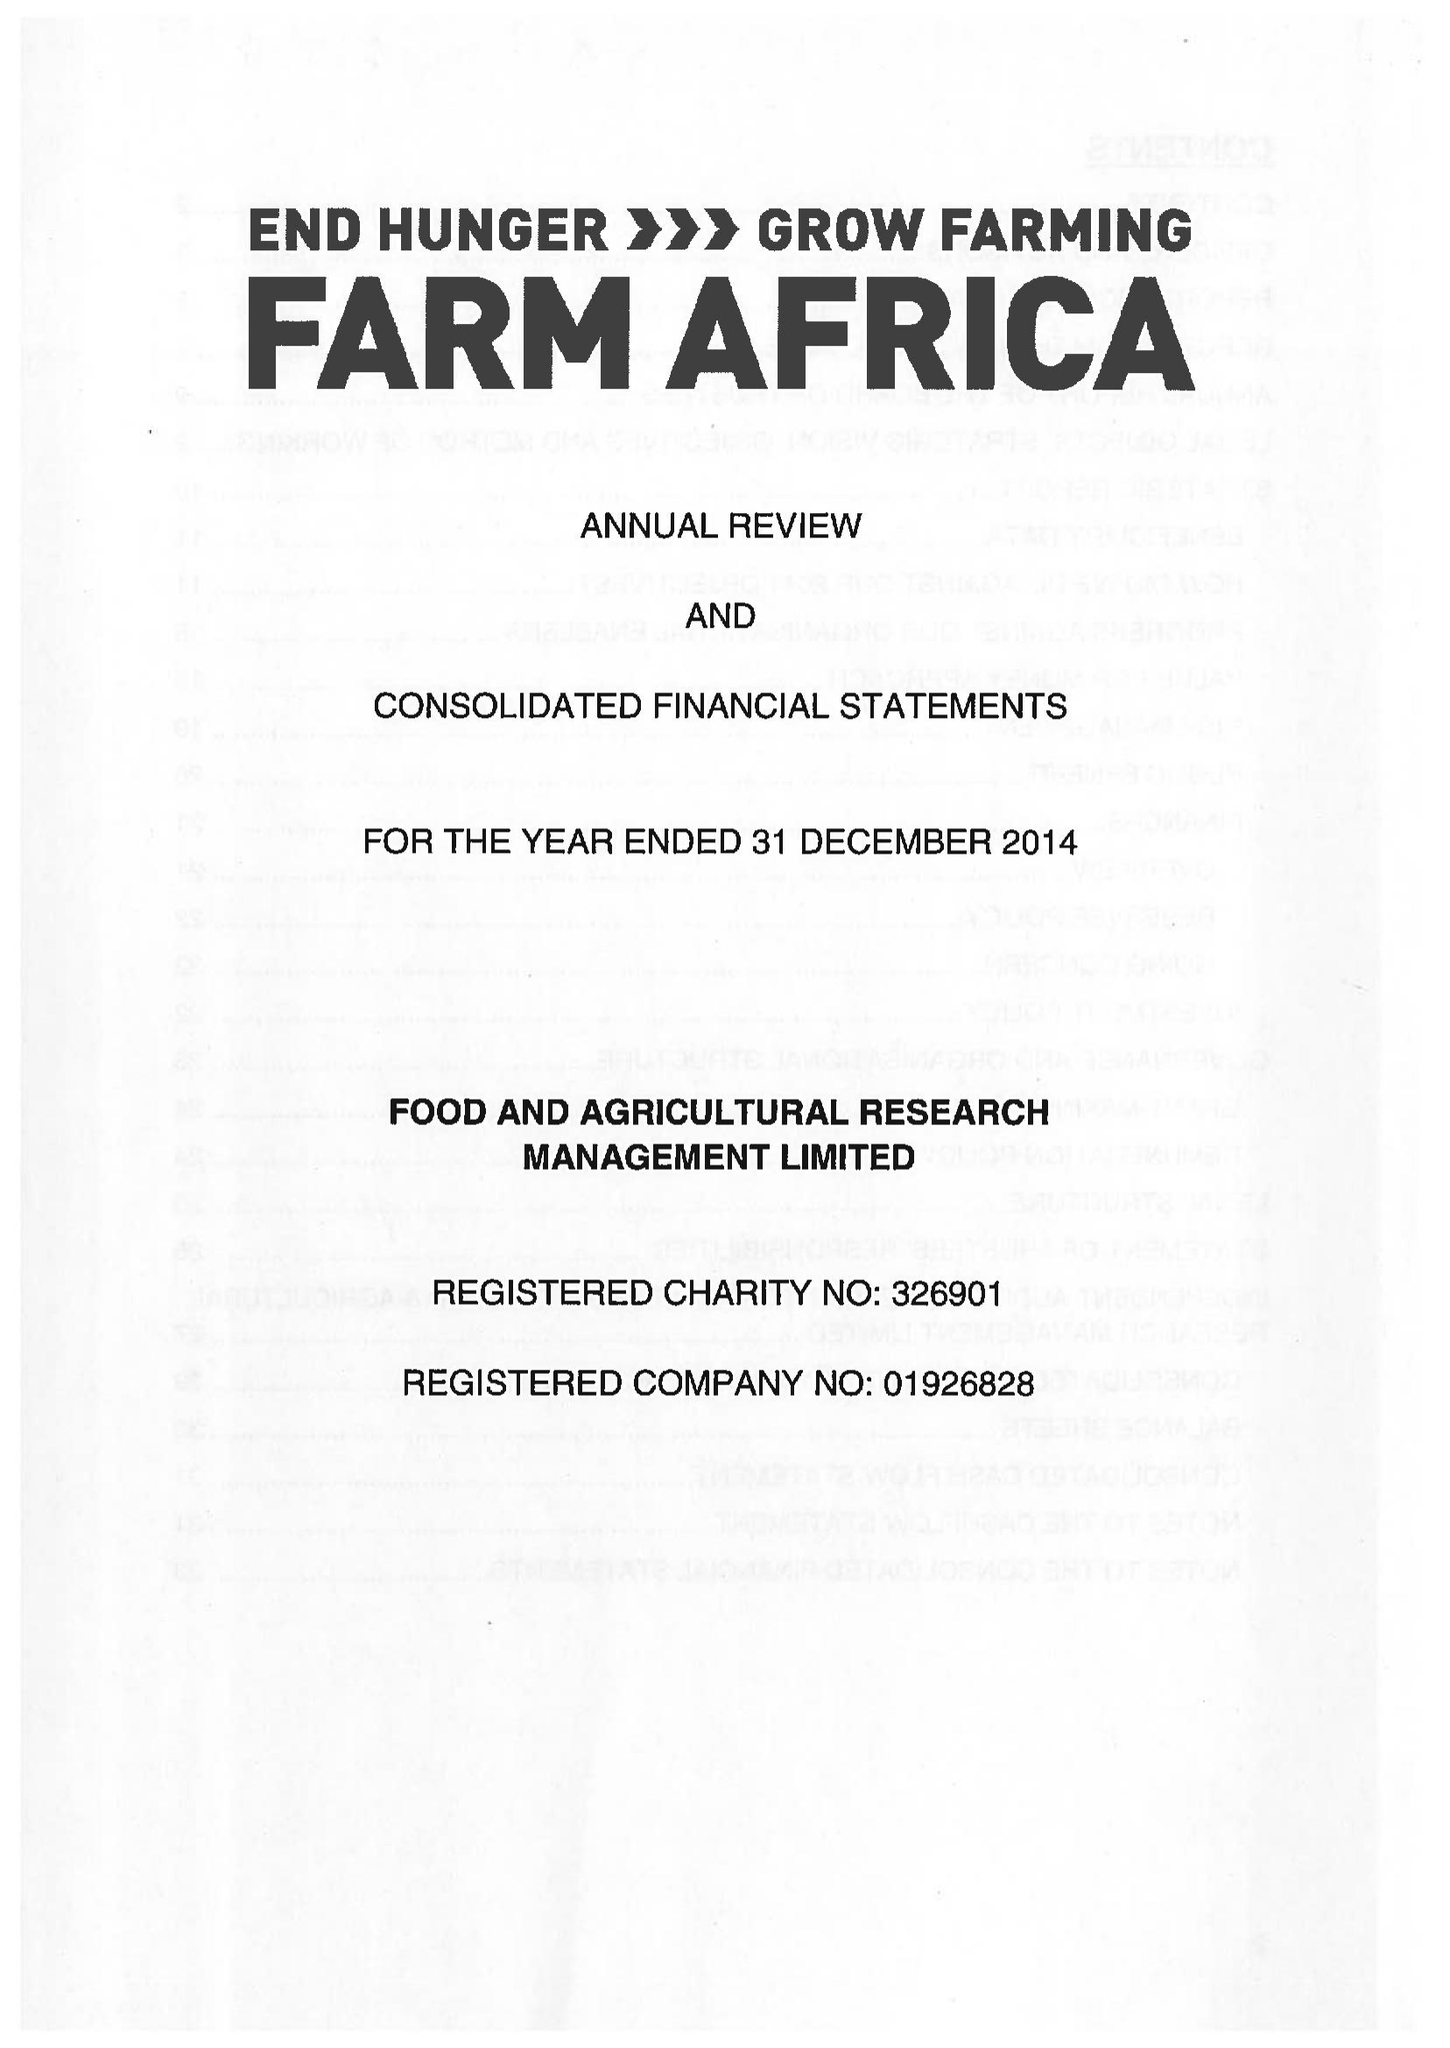What is the value for the income_annually_in_british_pounds?
Answer the question using a single word or phrase. 13784000.00 